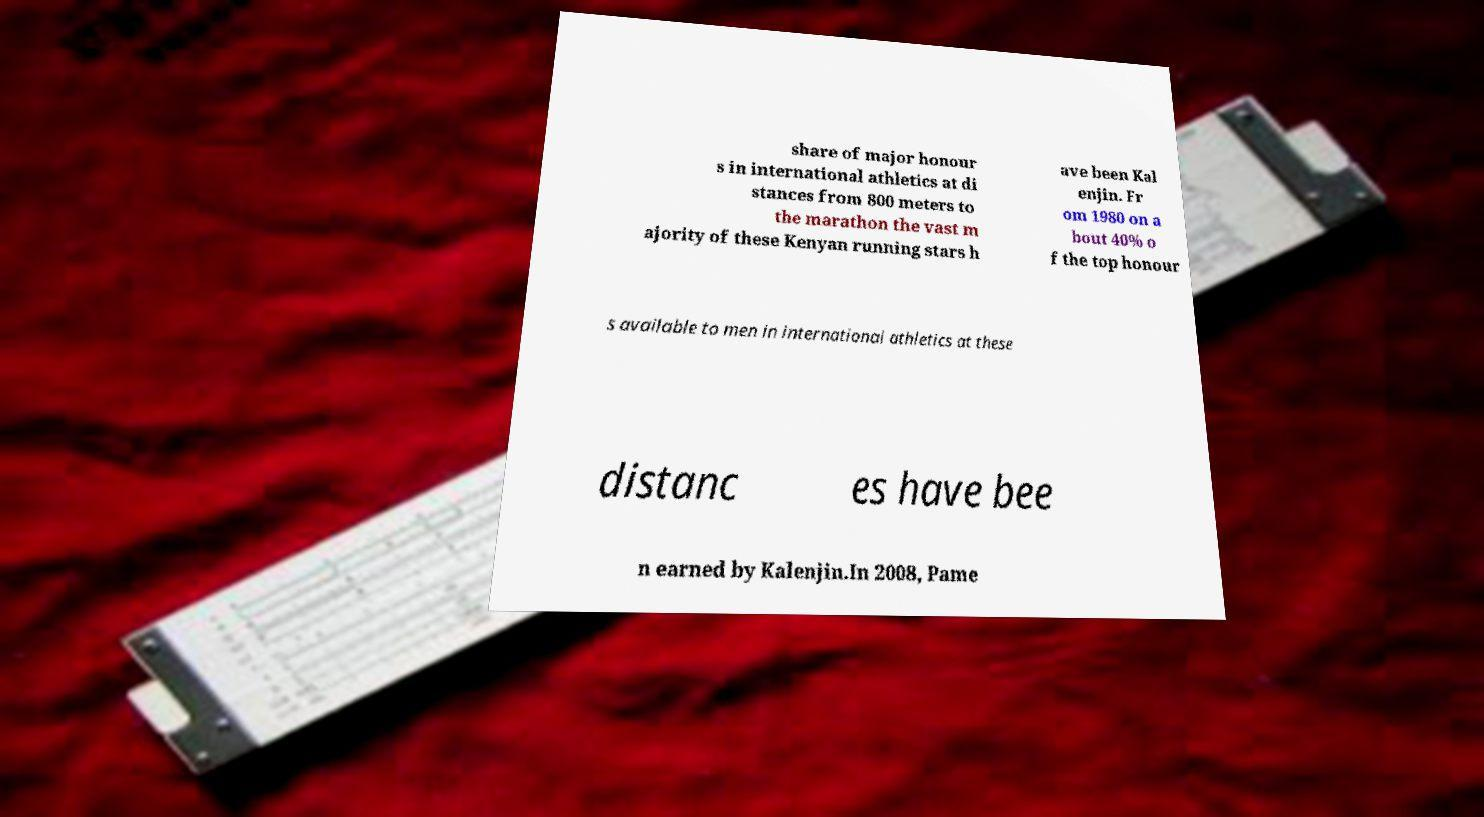Could you extract and type out the text from this image? share of major honour s in international athletics at di stances from 800 meters to the marathon the vast m ajority of these Kenyan running stars h ave been Kal enjin. Fr om 1980 on a bout 40% o f the top honour s available to men in international athletics at these distanc es have bee n earned by Kalenjin.In 2008, Pame 